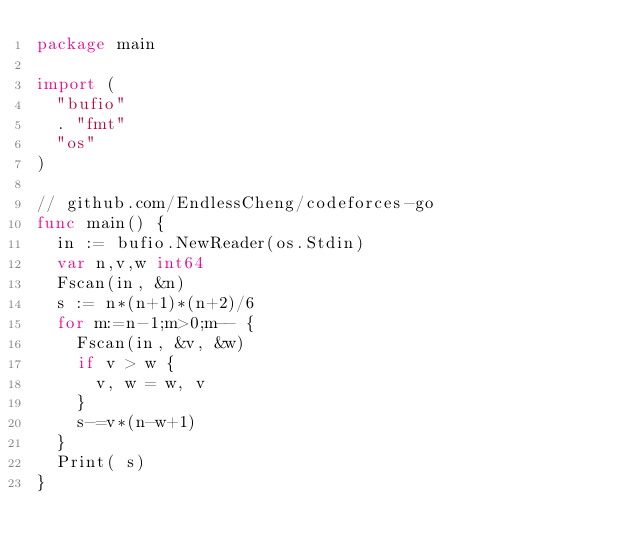<code> <loc_0><loc_0><loc_500><loc_500><_Go_>package main

import (
	"bufio"
	. "fmt"
	"os"
)

// github.com/EndlessCheng/codeforces-go
func main() {
	in := bufio.NewReader(os.Stdin)
	var n,v,w int64
	Fscan(in, &n)
	s := n*(n+1)*(n+2)/6
	for m:=n-1;m>0;m-- {
		Fscan(in, &v, &w)
		if v > w {
			v, w = w, v
		}
		s-=v*(n-w+1)
	}
	Print( s)
}
</code> 